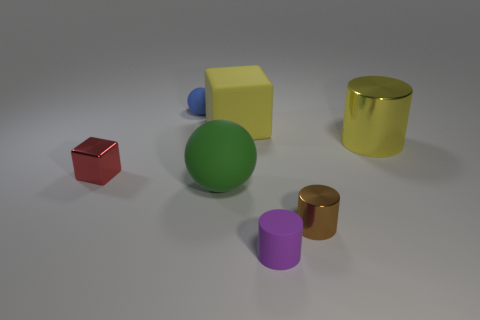There is a shiny cylinder that is the same size as the yellow cube; what color is it?
Your response must be concise. Yellow. How many shiny things are in front of the small metal thing that is behind the brown metal cylinder?
Ensure brevity in your answer.  1. How many objects are big cylinders that are behind the green rubber ball or big rubber things?
Your response must be concise. 3. How many brown things have the same material as the small purple thing?
Provide a short and direct response. 0. There is a metallic thing that is the same color as the big matte cube; what shape is it?
Your answer should be compact. Cylinder. Are there the same number of purple rubber things that are right of the brown object and yellow things?
Give a very brief answer. No. How big is the yellow block that is behind the purple cylinder?
Provide a succinct answer. Large. How many large objects are either brown spheres or yellow blocks?
Your answer should be compact. 1. What color is the other thing that is the same shape as the green rubber object?
Your answer should be compact. Blue. Is the size of the matte cylinder the same as the yellow metallic cylinder?
Provide a succinct answer. No. 